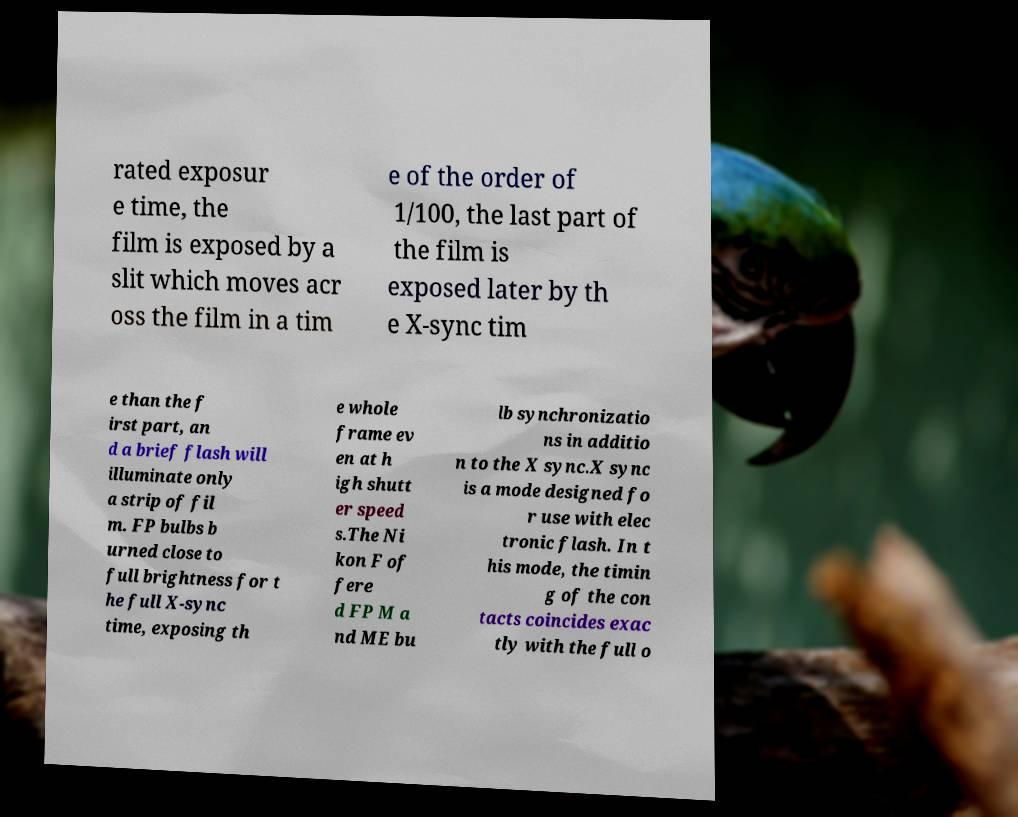For documentation purposes, I need the text within this image transcribed. Could you provide that? rated exposur e time, the film is exposed by a slit which moves acr oss the film in a tim e of the order of 1/100, the last part of the film is exposed later by th e X-sync tim e than the f irst part, an d a brief flash will illuminate only a strip of fil m. FP bulbs b urned close to full brightness for t he full X-sync time, exposing th e whole frame ev en at h igh shutt er speed s.The Ni kon F of fere d FP M a nd ME bu lb synchronizatio ns in additio n to the X sync.X sync is a mode designed fo r use with elec tronic flash. In t his mode, the timin g of the con tacts coincides exac tly with the full o 